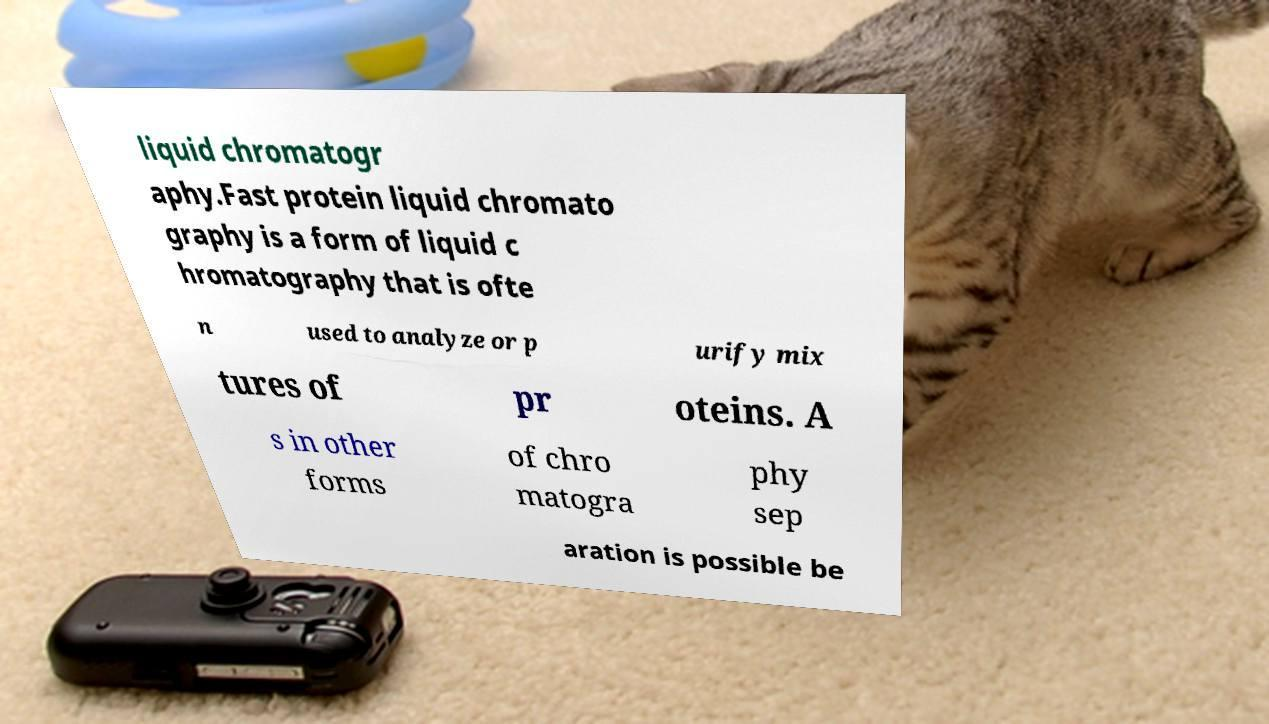Can you accurately transcribe the text from the provided image for me? liquid chromatogr aphy.Fast protein liquid chromato graphy is a form of liquid c hromatography that is ofte n used to analyze or p urify mix tures of pr oteins. A s in other forms of chro matogra phy sep aration is possible be 